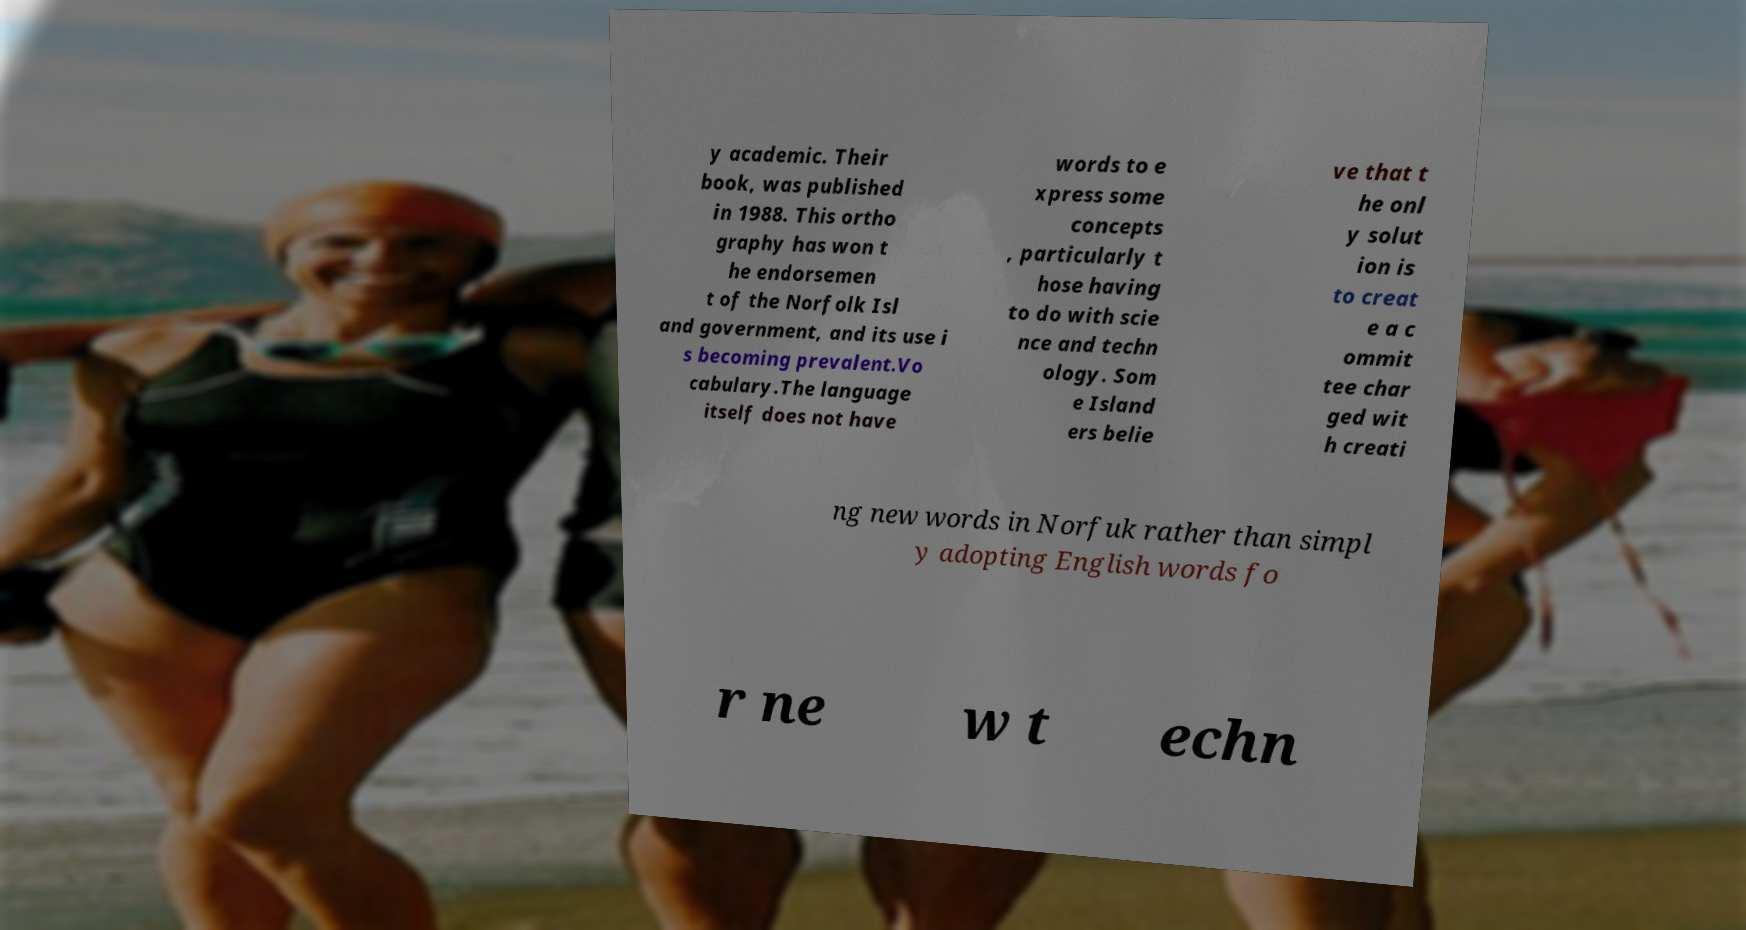Can you read and provide the text displayed in the image?This photo seems to have some interesting text. Can you extract and type it out for me? y academic. Their book, was published in 1988. This ortho graphy has won t he endorsemen t of the Norfolk Isl and government, and its use i s becoming prevalent.Vo cabulary.The language itself does not have words to e xpress some concepts , particularly t hose having to do with scie nce and techn ology. Som e Island ers belie ve that t he onl y solut ion is to creat e a c ommit tee char ged wit h creati ng new words in Norfuk rather than simpl y adopting English words fo r ne w t echn 